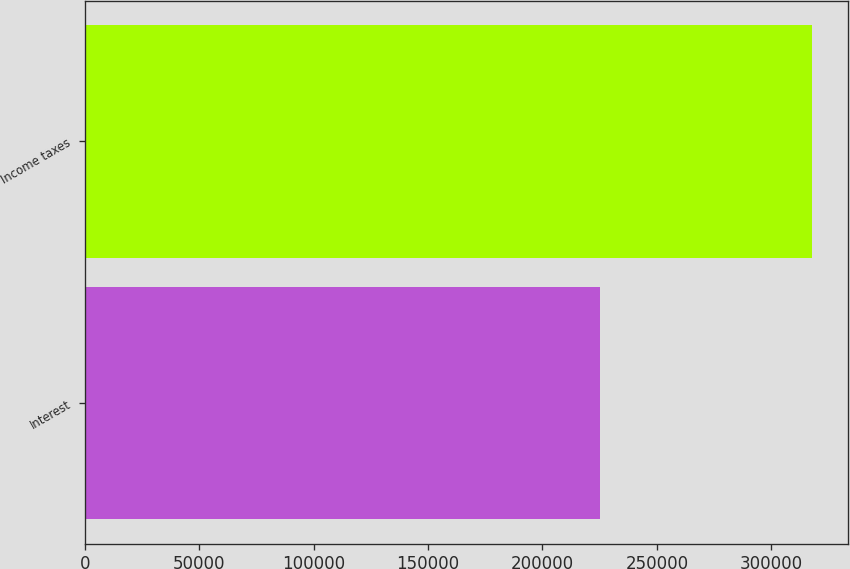Convert chart. <chart><loc_0><loc_0><loc_500><loc_500><bar_chart><fcel>Interest<fcel>Income taxes<nl><fcel>225228<fcel>317812<nl></chart> 